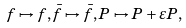Convert formula to latex. <formula><loc_0><loc_0><loc_500><loc_500>f \mapsto f , \bar { f } \mapsto \bar { f } , P \mapsto P + \varepsilon P ,</formula> 